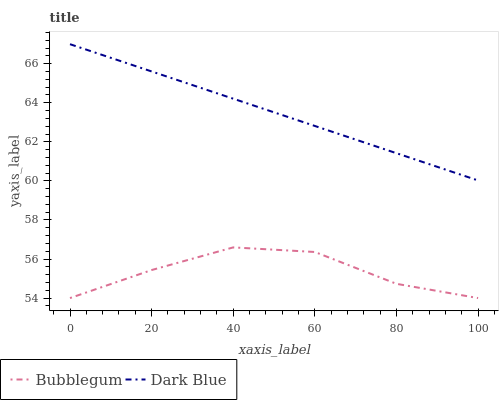Does Bubblegum have the minimum area under the curve?
Answer yes or no. Yes. Does Dark Blue have the maximum area under the curve?
Answer yes or no. Yes. Does Bubblegum have the maximum area under the curve?
Answer yes or no. No. Is Dark Blue the smoothest?
Answer yes or no. Yes. Is Bubblegum the roughest?
Answer yes or no. Yes. Is Bubblegum the smoothest?
Answer yes or no. No. Does Bubblegum have the lowest value?
Answer yes or no. Yes. Does Dark Blue have the highest value?
Answer yes or no. Yes. Does Bubblegum have the highest value?
Answer yes or no. No. Is Bubblegum less than Dark Blue?
Answer yes or no. Yes. Is Dark Blue greater than Bubblegum?
Answer yes or no. Yes. Does Bubblegum intersect Dark Blue?
Answer yes or no. No. 